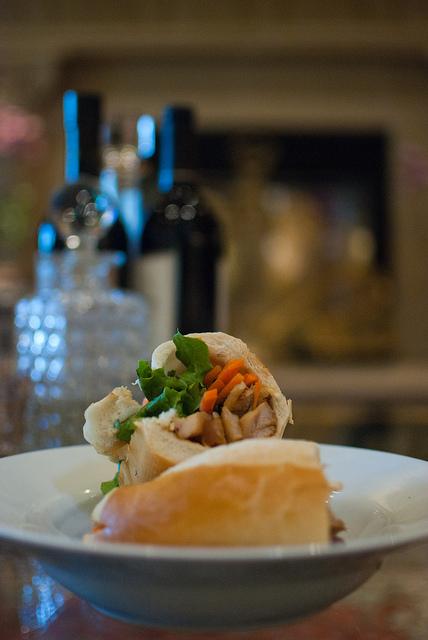Does the sandwich look grilled?
Be succinct. No. What is in the white bowl already cut up?
Keep it brief. Sandwich. Are there French fries?
Concise answer only. No. Is there a glass vase?
Keep it brief. No. Is this a high class dish?
Short answer required. No. Is this meal more likely to be breakfast, lunch, or dinner?
Write a very short answer. Lunch. What vegetable is seen on the dish?
Answer briefly. Carrot. Is this a healthy meal?
Concise answer only. Yes. What kind of vegetables are in that sandwich?
Answer briefly. Lettuce and carrots. Is the food designed?
Give a very brief answer. Yes. What is in the background?
Be succinct. Wine. Is there a beef or chicken hot dog?
Be succinct. Chicken. Does the dish have polka dots on it?
Concise answer only. No. 